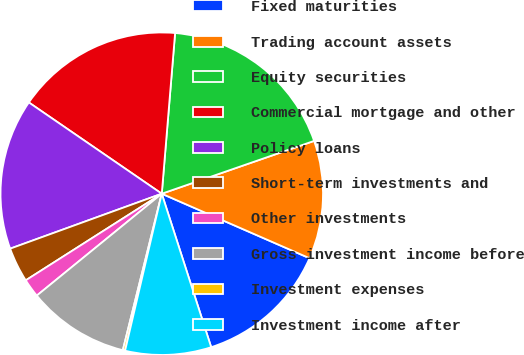Convert chart. <chart><loc_0><loc_0><loc_500><loc_500><pie_chart><fcel>Fixed maturities<fcel>Trading account assets<fcel>Equity securities<fcel>Commercial mortgage and other<fcel>Policy loans<fcel>Short-term investments and<fcel>Other investments<fcel>Gross investment income before<fcel>Investment expenses<fcel>Investment income after<nl><fcel>13.49%<fcel>11.86%<fcel>18.37%<fcel>16.74%<fcel>15.11%<fcel>3.49%<fcel>1.86%<fcel>10.23%<fcel>0.23%<fcel>8.61%<nl></chart> 